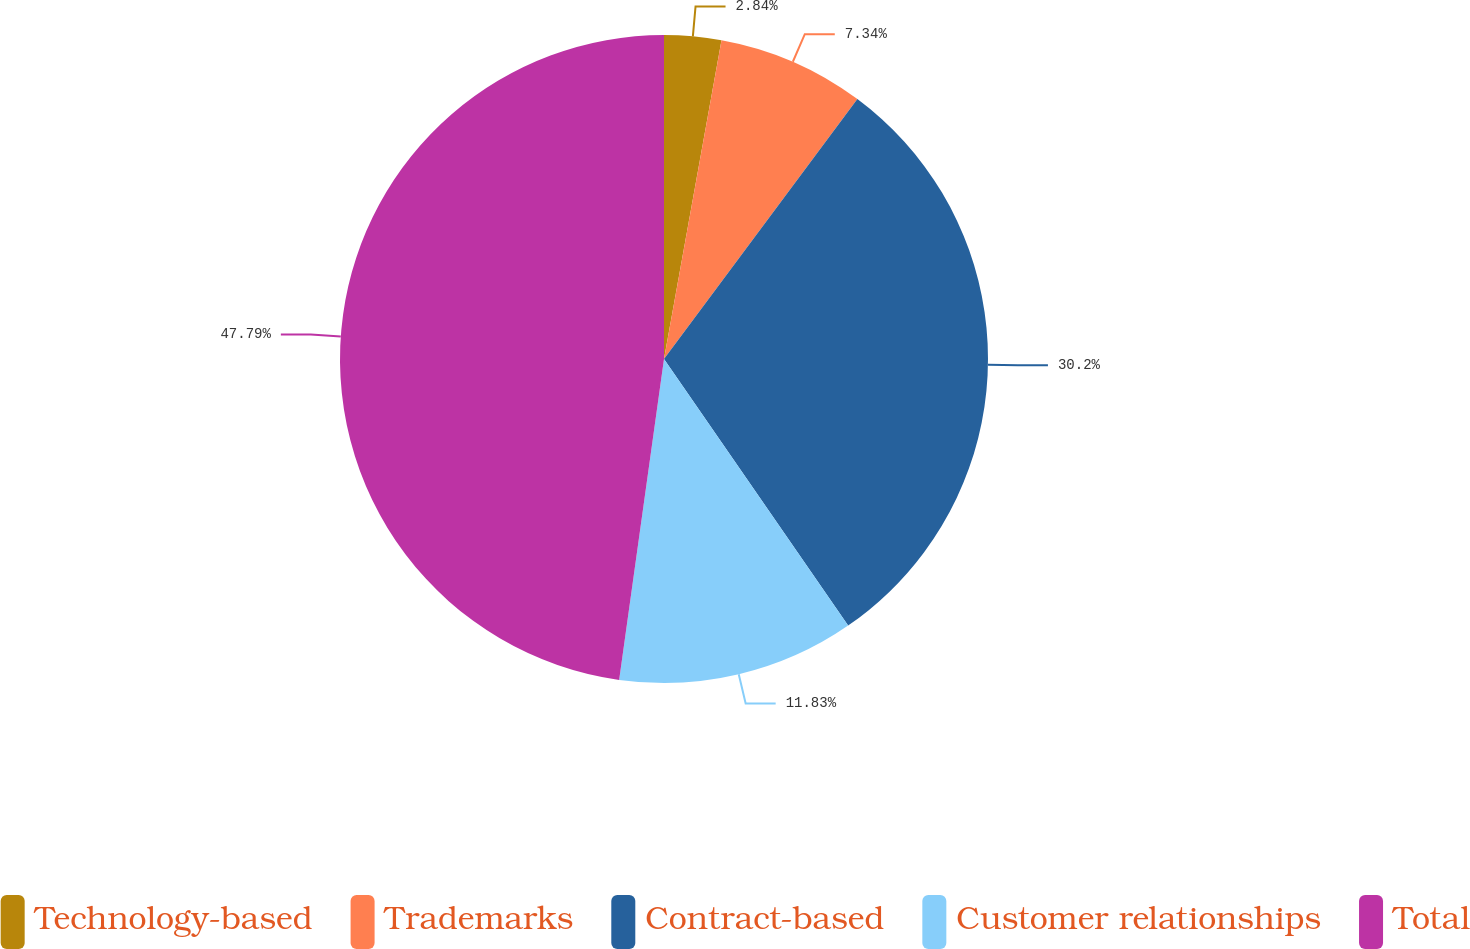Convert chart to OTSL. <chart><loc_0><loc_0><loc_500><loc_500><pie_chart><fcel>Technology-based<fcel>Trademarks<fcel>Contract-based<fcel>Customer relationships<fcel>Total<nl><fcel>2.84%<fcel>7.34%<fcel>30.2%<fcel>11.83%<fcel>47.79%<nl></chart> 